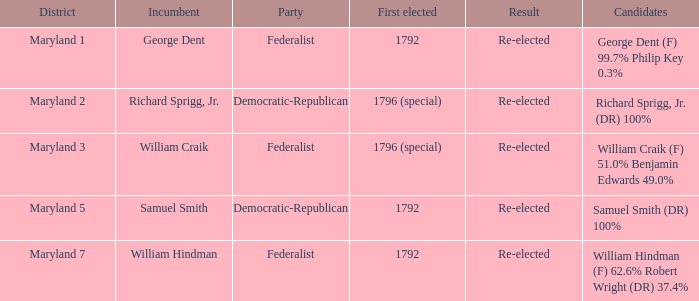0% and benjamin edwards at 4 Maryland 3. 